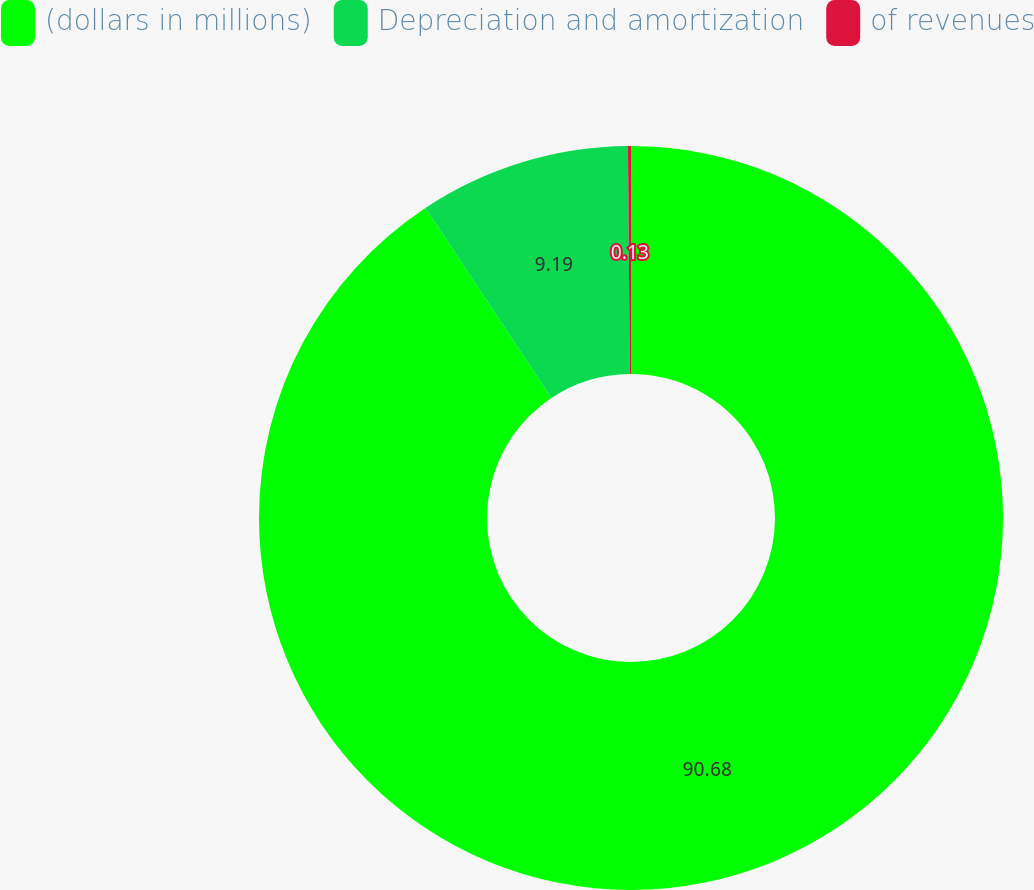<chart> <loc_0><loc_0><loc_500><loc_500><pie_chart><fcel>(dollars in millions)<fcel>Depreciation and amortization<fcel>of revenues<nl><fcel>90.68%<fcel>9.19%<fcel>0.13%<nl></chart> 